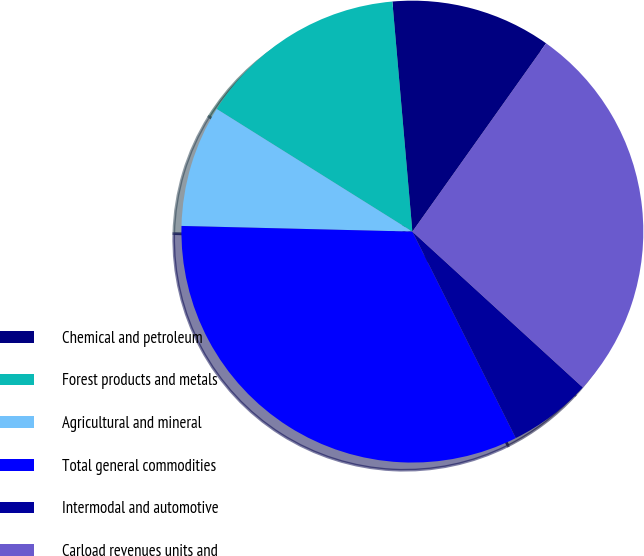<chart> <loc_0><loc_0><loc_500><loc_500><pie_chart><fcel>Chemical and petroleum<fcel>Forest products and metals<fcel>Agricultural and mineral<fcel>Total general commodities<fcel>Intermodal and automotive<fcel>Carload revenues units and<nl><fcel>11.21%<fcel>14.71%<fcel>8.52%<fcel>32.78%<fcel>5.82%<fcel>26.96%<nl></chart> 